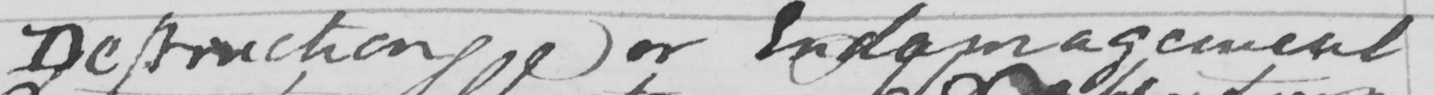What text is written in this handwritten line? Destruction or Endamagement 